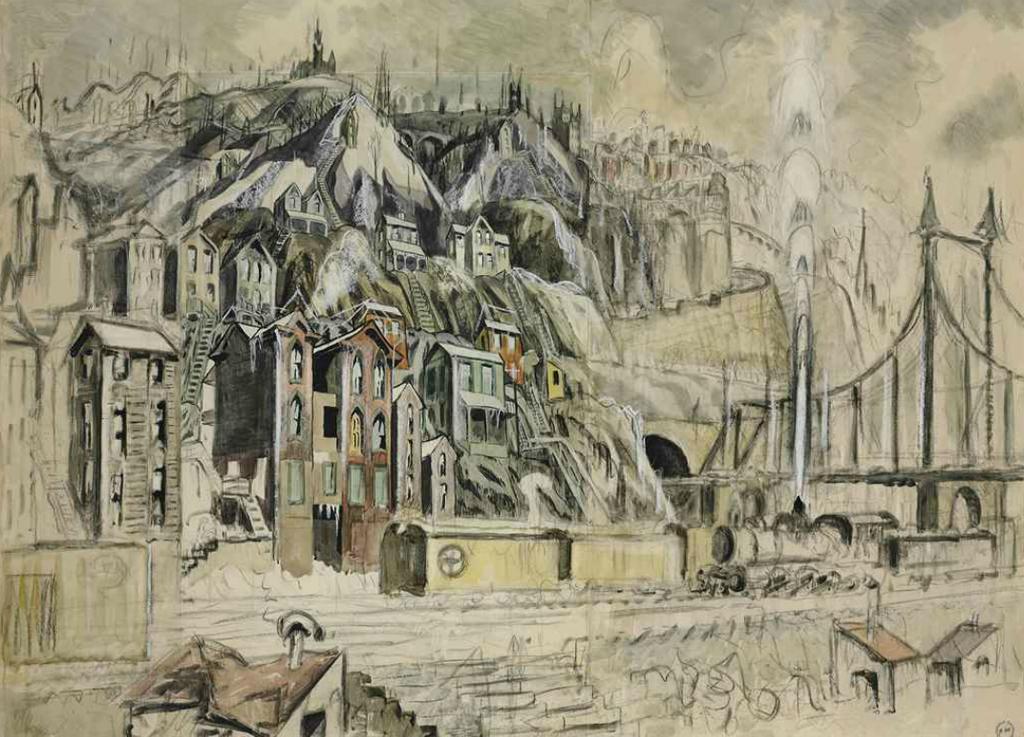Could you give a brief overview of what you see in this image? In this image the painting is seen. And we can see the ancient buildings and many windows are there. And on the right side two towers are seen. And many small houses are seen at the bottom. 